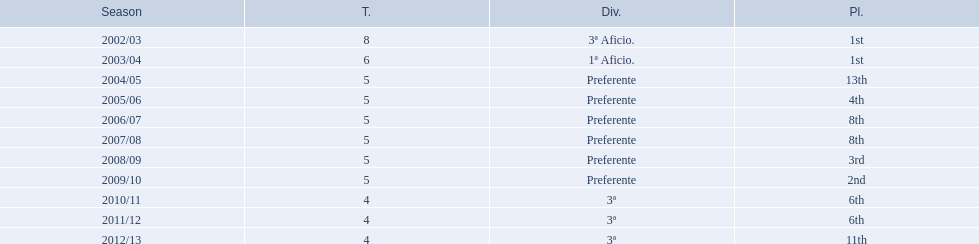How many times did  internacional de madrid cf come in 6th place? 6th, 6th. What is the first season that the team came in 6th place? 2010/11. Which season after the first did they place in 6th again? 2011/12. 